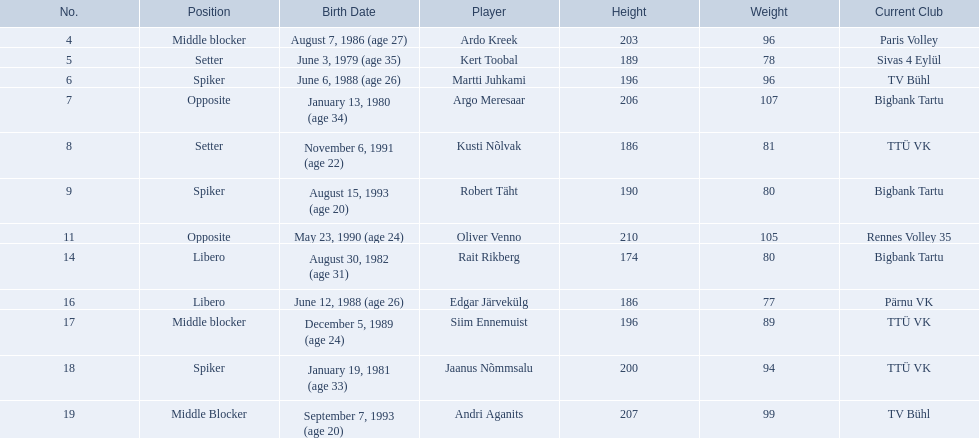Who are the players of the estonian men's national volleyball team? Ardo Kreek, Kert Toobal, Martti Juhkami, Argo Meresaar, Kusti Nõlvak, Robert Täht, Oliver Venno, Rait Rikberg, Edgar Järvekülg, Siim Ennemuist, Jaanus Nõmmsalu, Andri Aganits. Of these, which have a height over 200? Ardo Kreek, Argo Meresaar, Oliver Venno, Andri Aganits. Of the remaining, who is the tallest? Oliver Venno. 